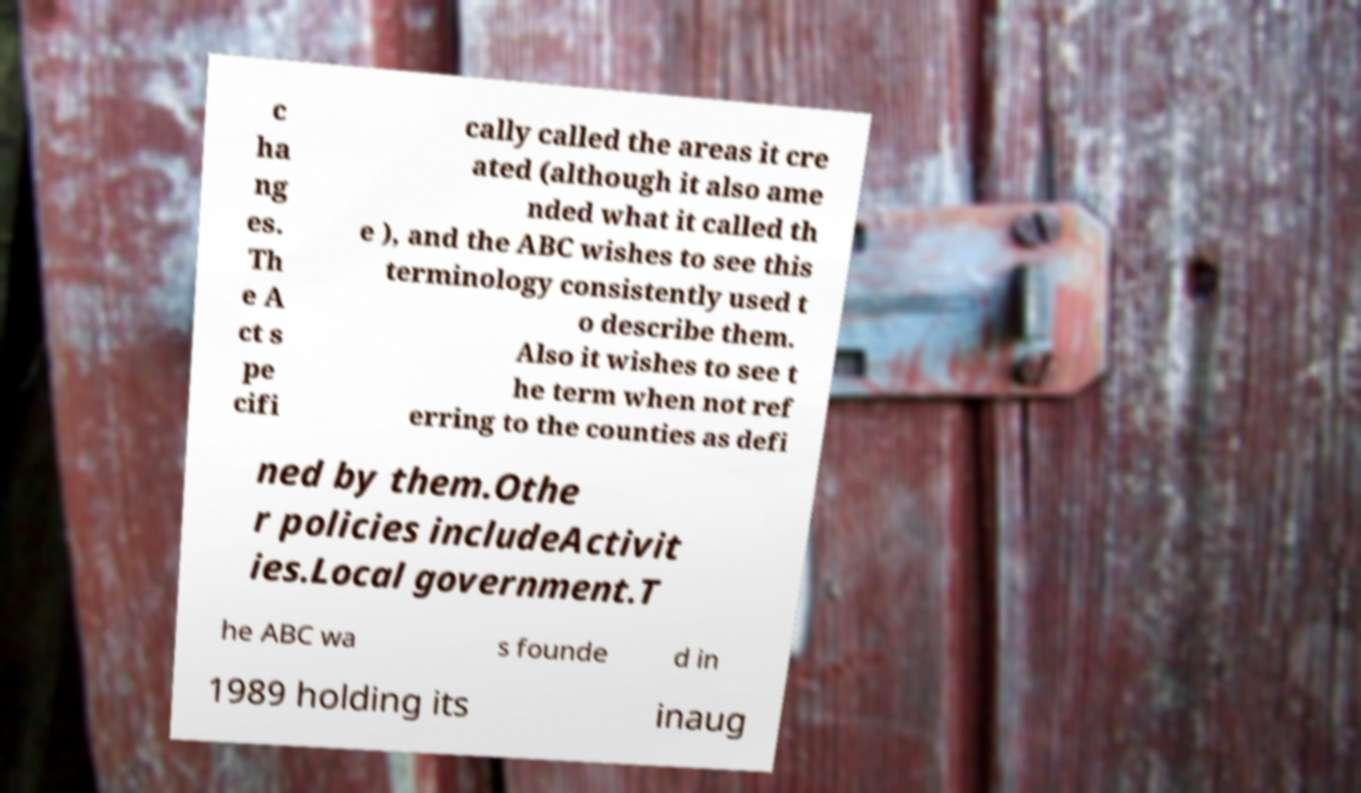For documentation purposes, I need the text within this image transcribed. Could you provide that? c ha ng es. Th e A ct s pe cifi cally called the areas it cre ated (although it also ame nded what it called th e ), and the ABC wishes to see this terminology consistently used t o describe them. Also it wishes to see t he term when not ref erring to the counties as defi ned by them.Othe r policies includeActivit ies.Local government.T he ABC wa s founde d in 1989 holding its inaug 